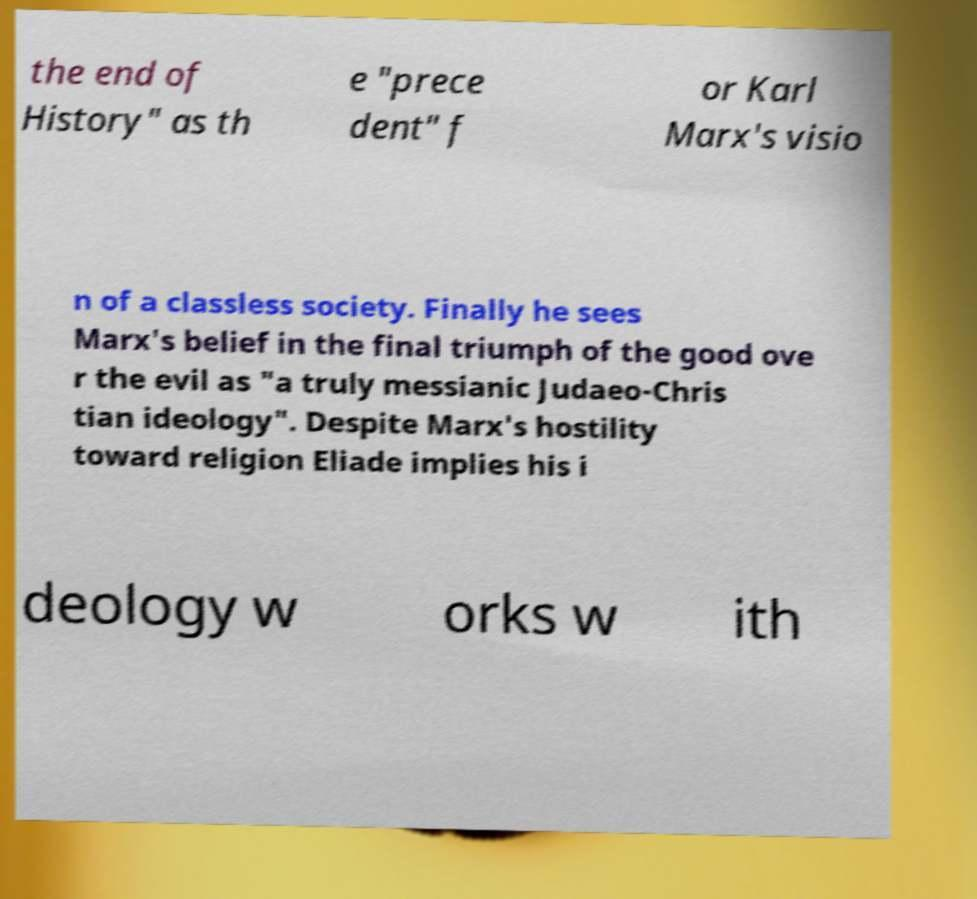Can you read and provide the text displayed in the image?This photo seems to have some interesting text. Can you extract and type it out for me? the end of History" as th e "prece dent" f or Karl Marx's visio n of a classless society. Finally he sees Marx's belief in the final triumph of the good ove r the evil as "a truly messianic Judaeo-Chris tian ideology". Despite Marx's hostility toward religion Eliade implies his i deology w orks w ith 